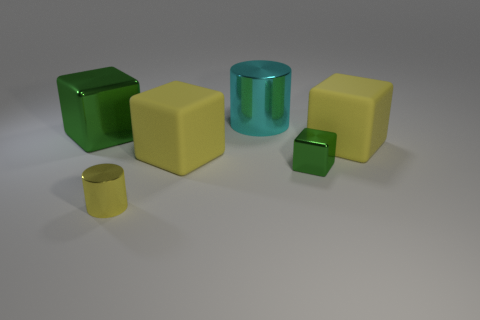Add 4 small green shiny objects. How many objects exist? 10 Subtract all blocks. How many objects are left? 2 Add 1 big shiny cubes. How many big shiny cubes are left? 2 Add 5 tiny cylinders. How many tiny cylinders exist? 6 Subtract 1 yellow blocks. How many objects are left? 5 Subtract all cyan metal things. Subtract all big green cubes. How many objects are left? 4 